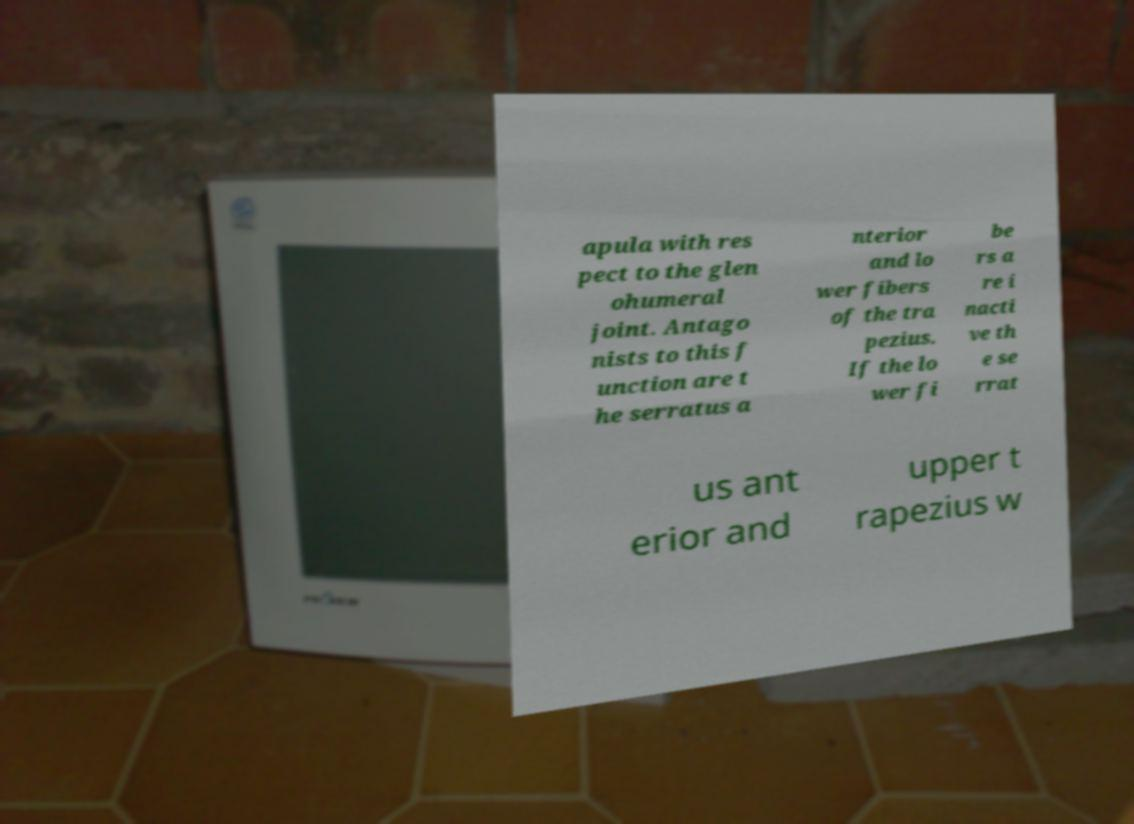There's text embedded in this image that I need extracted. Can you transcribe it verbatim? apula with res pect to the glen ohumeral joint. Antago nists to this f unction are t he serratus a nterior and lo wer fibers of the tra pezius. If the lo wer fi be rs a re i nacti ve th e se rrat us ant erior and upper t rapezius w 